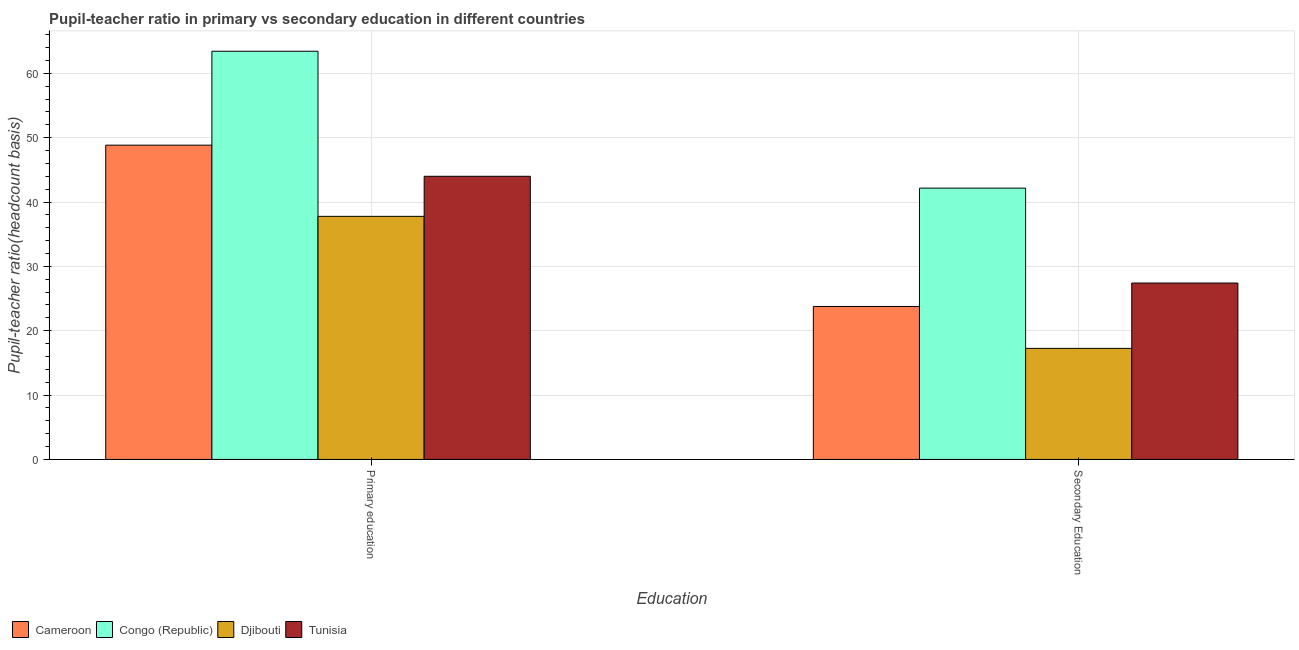How many bars are there on the 2nd tick from the left?
Make the answer very short. 4. How many bars are there on the 1st tick from the right?
Your response must be concise. 4. What is the label of the 1st group of bars from the left?
Give a very brief answer. Primary education. What is the pupil teacher ratio on secondary education in Djibouti?
Give a very brief answer. 17.26. Across all countries, what is the maximum pupil-teacher ratio in primary education?
Keep it short and to the point. 63.43. Across all countries, what is the minimum pupil teacher ratio on secondary education?
Ensure brevity in your answer.  17.26. In which country was the pupil teacher ratio on secondary education maximum?
Your answer should be very brief. Congo (Republic). In which country was the pupil-teacher ratio in primary education minimum?
Keep it short and to the point. Djibouti. What is the total pupil teacher ratio on secondary education in the graph?
Give a very brief answer. 110.6. What is the difference between the pupil-teacher ratio in primary education in Tunisia and that in Congo (Republic)?
Your answer should be compact. -19.43. What is the difference between the pupil-teacher ratio in primary education in Tunisia and the pupil teacher ratio on secondary education in Congo (Republic)?
Provide a succinct answer. 1.84. What is the average pupil teacher ratio on secondary education per country?
Offer a terse response. 27.65. What is the difference between the pupil teacher ratio on secondary education and pupil-teacher ratio in primary education in Tunisia?
Offer a very short reply. -16.59. What is the ratio of the pupil teacher ratio on secondary education in Tunisia to that in Djibouti?
Offer a very short reply. 1.59. In how many countries, is the pupil teacher ratio on secondary education greater than the average pupil teacher ratio on secondary education taken over all countries?
Make the answer very short. 1. What does the 2nd bar from the left in Secondary Education represents?
Your answer should be compact. Congo (Republic). What does the 4th bar from the right in Secondary Education represents?
Make the answer very short. Cameroon. How many bars are there?
Make the answer very short. 8. What is the difference between two consecutive major ticks on the Y-axis?
Make the answer very short. 10. Are the values on the major ticks of Y-axis written in scientific E-notation?
Give a very brief answer. No. Where does the legend appear in the graph?
Offer a very short reply. Bottom left. How are the legend labels stacked?
Make the answer very short. Horizontal. What is the title of the graph?
Keep it short and to the point. Pupil-teacher ratio in primary vs secondary education in different countries. What is the label or title of the X-axis?
Keep it short and to the point. Education. What is the label or title of the Y-axis?
Offer a very short reply. Pupil-teacher ratio(headcount basis). What is the Pupil-teacher ratio(headcount basis) in Cameroon in Primary education?
Offer a very short reply. 48.83. What is the Pupil-teacher ratio(headcount basis) in Congo (Republic) in Primary education?
Offer a terse response. 63.43. What is the Pupil-teacher ratio(headcount basis) of Djibouti in Primary education?
Your answer should be very brief. 37.77. What is the Pupil-teacher ratio(headcount basis) of Tunisia in Primary education?
Offer a terse response. 44. What is the Pupil-teacher ratio(headcount basis) in Cameroon in Secondary Education?
Offer a terse response. 23.77. What is the Pupil-teacher ratio(headcount basis) of Congo (Republic) in Secondary Education?
Offer a very short reply. 42.16. What is the Pupil-teacher ratio(headcount basis) of Djibouti in Secondary Education?
Your answer should be compact. 17.26. What is the Pupil-teacher ratio(headcount basis) in Tunisia in Secondary Education?
Keep it short and to the point. 27.41. Across all Education, what is the maximum Pupil-teacher ratio(headcount basis) of Cameroon?
Your response must be concise. 48.83. Across all Education, what is the maximum Pupil-teacher ratio(headcount basis) in Congo (Republic)?
Provide a short and direct response. 63.43. Across all Education, what is the maximum Pupil-teacher ratio(headcount basis) in Djibouti?
Your answer should be very brief. 37.77. Across all Education, what is the maximum Pupil-teacher ratio(headcount basis) of Tunisia?
Offer a very short reply. 44. Across all Education, what is the minimum Pupil-teacher ratio(headcount basis) of Cameroon?
Provide a short and direct response. 23.77. Across all Education, what is the minimum Pupil-teacher ratio(headcount basis) in Congo (Republic)?
Your answer should be compact. 42.16. Across all Education, what is the minimum Pupil-teacher ratio(headcount basis) in Djibouti?
Ensure brevity in your answer.  17.26. Across all Education, what is the minimum Pupil-teacher ratio(headcount basis) of Tunisia?
Your answer should be very brief. 27.41. What is the total Pupil-teacher ratio(headcount basis) of Cameroon in the graph?
Provide a short and direct response. 72.6. What is the total Pupil-teacher ratio(headcount basis) in Congo (Republic) in the graph?
Your response must be concise. 105.59. What is the total Pupil-teacher ratio(headcount basis) in Djibouti in the graph?
Keep it short and to the point. 55.03. What is the total Pupil-teacher ratio(headcount basis) in Tunisia in the graph?
Your answer should be compact. 71.41. What is the difference between the Pupil-teacher ratio(headcount basis) in Cameroon in Primary education and that in Secondary Education?
Your answer should be very brief. 25.07. What is the difference between the Pupil-teacher ratio(headcount basis) in Congo (Republic) in Primary education and that in Secondary Education?
Provide a succinct answer. 21.27. What is the difference between the Pupil-teacher ratio(headcount basis) in Djibouti in Primary education and that in Secondary Education?
Make the answer very short. 20.51. What is the difference between the Pupil-teacher ratio(headcount basis) in Tunisia in Primary education and that in Secondary Education?
Offer a very short reply. 16.59. What is the difference between the Pupil-teacher ratio(headcount basis) in Cameroon in Primary education and the Pupil-teacher ratio(headcount basis) in Congo (Republic) in Secondary Education?
Your answer should be very brief. 6.67. What is the difference between the Pupil-teacher ratio(headcount basis) of Cameroon in Primary education and the Pupil-teacher ratio(headcount basis) of Djibouti in Secondary Education?
Your response must be concise. 31.58. What is the difference between the Pupil-teacher ratio(headcount basis) in Cameroon in Primary education and the Pupil-teacher ratio(headcount basis) in Tunisia in Secondary Education?
Keep it short and to the point. 21.43. What is the difference between the Pupil-teacher ratio(headcount basis) in Congo (Republic) in Primary education and the Pupil-teacher ratio(headcount basis) in Djibouti in Secondary Education?
Offer a very short reply. 46.17. What is the difference between the Pupil-teacher ratio(headcount basis) in Congo (Republic) in Primary education and the Pupil-teacher ratio(headcount basis) in Tunisia in Secondary Education?
Offer a terse response. 36.02. What is the difference between the Pupil-teacher ratio(headcount basis) of Djibouti in Primary education and the Pupil-teacher ratio(headcount basis) of Tunisia in Secondary Education?
Your response must be concise. 10.36. What is the average Pupil-teacher ratio(headcount basis) in Cameroon per Education?
Give a very brief answer. 36.3. What is the average Pupil-teacher ratio(headcount basis) in Congo (Republic) per Education?
Keep it short and to the point. 52.8. What is the average Pupil-teacher ratio(headcount basis) of Djibouti per Education?
Offer a terse response. 27.51. What is the average Pupil-teacher ratio(headcount basis) in Tunisia per Education?
Provide a short and direct response. 35.7. What is the difference between the Pupil-teacher ratio(headcount basis) in Cameroon and Pupil-teacher ratio(headcount basis) in Congo (Republic) in Primary education?
Provide a succinct answer. -14.6. What is the difference between the Pupil-teacher ratio(headcount basis) of Cameroon and Pupil-teacher ratio(headcount basis) of Djibouti in Primary education?
Offer a terse response. 11.06. What is the difference between the Pupil-teacher ratio(headcount basis) of Cameroon and Pupil-teacher ratio(headcount basis) of Tunisia in Primary education?
Ensure brevity in your answer.  4.84. What is the difference between the Pupil-teacher ratio(headcount basis) in Congo (Republic) and Pupil-teacher ratio(headcount basis) in Djibouti in Primary education?
Provide a short and direct response. 25.66. What is the difference between the Pupil-teacher ratio(headcount basis) in Congo (Republic) and Pupil-teacher ratio(headcount basis) in Tunisia in Primary education?
Provide a short and direct response. 19.43. What is the difference between the Pupil-teacher ratio(headcount basis) of Djibouti and Pupil-teacher ratio(headcount basis) of Tunisia in Primary education?
Give a very brief answer. -6.23. What is the difference between the Pupil-teacher ratio(headcount basis) of Cameroon and Pupil-teacher ratio(headcount basis) of Congo (Republic) in Secondary Education?
Keep it short and to the point. -18.39. What is the difference between the Pupil-teacher ratio(headcount basis) of Cameroon and Pupil-teacher ratio(headcount basis) of Djibouti in Secondary Education?
Keep it short and to the point. 6.51. What is the difference between the Pupil-teacher ratio(headcount basis) of Cameroon and Pupil-teacher ratio(headcount basis) of Tunisia in Secondary Education?
Ensure brevity in your answer.  -3.64. What is the difference between the Pupil-teacher ratio(headcount basis) of Congo (Republic) and Pupil-teacher ratio(headcount basis) of Djibouti in Secondary Education?
Your response must be concise. 24.9. What is the difference between the Pupil-teacher ratio(headcount basis) in Congo (Republic) and Pupil-teacher ratio(headcount basis) in Tunisia in Secondary Education?
Your response must be concise. 14.75. What is the difference between the Pupil-teacher ratio(headcount basis) in Djibouti and Pupil-teacher ratio(headcount basis) in Tunisia in Secondary Education?
Your response must be concise. -10.15. What is the ratio of the Pupil-teacher ratio(headcount basis) in Cameroon in Primary education to that in Secondary Education?
Your response must be concise. 2.05. What is the ratio of the Pupil-teacher ratio(headcount basis) of Congo (Republic) in Primary education to that in Secondary Education?
Offer a terse response. 1.5. What is the ratio of the Pupil-teacher ratio(headcount basis) in Djibouti in Primary education to that in Secondary Education?
Your response must be concise. 2.19. What is the ratio of the Pupil-teacher ratio(headcount basis) of Tunisia in Primary education to that in Secondary Education?
Provide a short and direct response. 1.61. What is the difference between the highest and the second highest Pupil-teacher ratio(headcount basis) of Cameroon?
Offer a terse response. 25.07. What is the difference between the highest and the second highest Pupil-teacher ratio(headcount basis) of Congo (Republic)?
Provide a succinct answer. 21.27. What is the difference between the highest and the second highest Pupil-teacher ratio(headcount basis) of Djibouti?
Ensure brevity in your answer.  20.51. What is the difference between the highest and the second highest Pupil-teacher ratio(headcount basis) of Tunisia?
Offer a very short reply. 16.59. What is the difference between the highest and the lowest Pupil-teacher ratio(headcount basis) in Cameroon?
Make the answer very short. 25.07. What is the difference between the highest and the lowest Pupil-teacher ratio(headcount basis) in Congo (Republic)?
Your response must be concise. 21.27. What is the difference between the highest and the lowest Pupil-teacher ratio(headcount basis) in Djibouti?
Your response must be concise. 20.51. What is the difference between the highest and the lowest Pupil-teacher ratio(headcount basis) in Tunisia?
Your answer should be very brief. 16.59. 